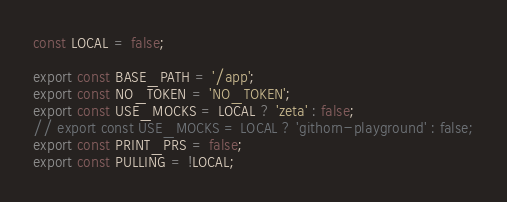<code> <loc_0><loc_0><loc_500><loc_500><_JavaScript_>const LOCAL = false;

export const BASE_PATH = '/app';
export const NO_TOKEN = 'NO_TOKEN';
export const USE_MOCKS = LOCAL ? 'zeta' : false;
// export const USE_MOCKS = LOCAL ? 'githorn-playground' : false;
export const PRINT_PRS = false;
export const PULLING = !LOCAL;
</code> 